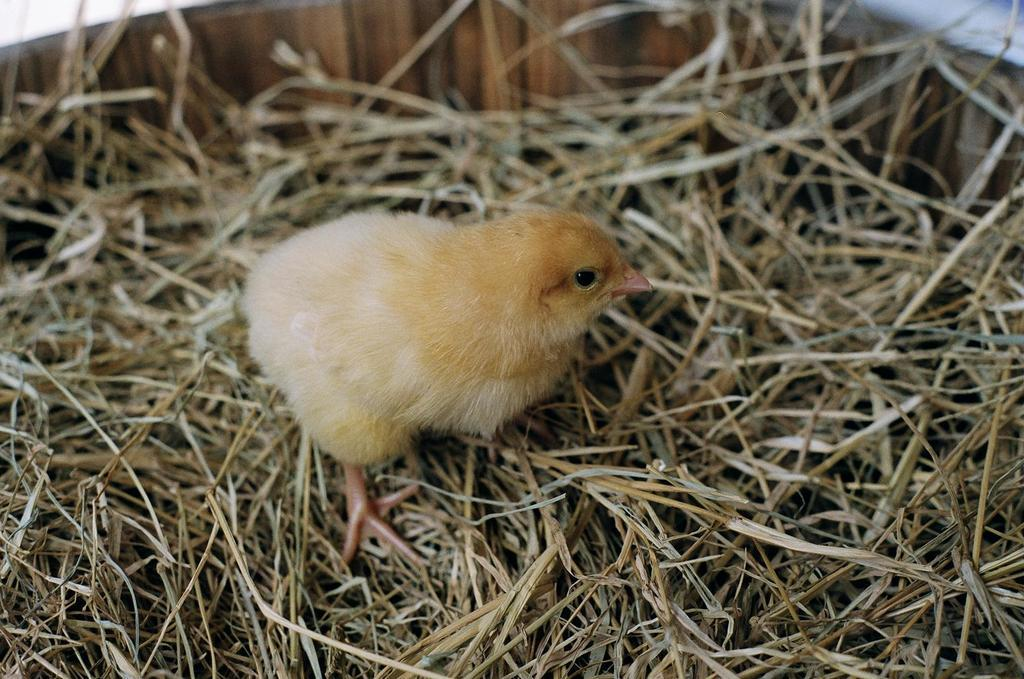What animal is present in the image? There is a chicken in the image. Where is the chicken located? The chicken is standing on the grass. What can be seen in the background of the image? There is a wooden object in the background of the image. How many rings are visible on the chicken's legs in the image? There are no rings visible on the chicken's legs in the image. 